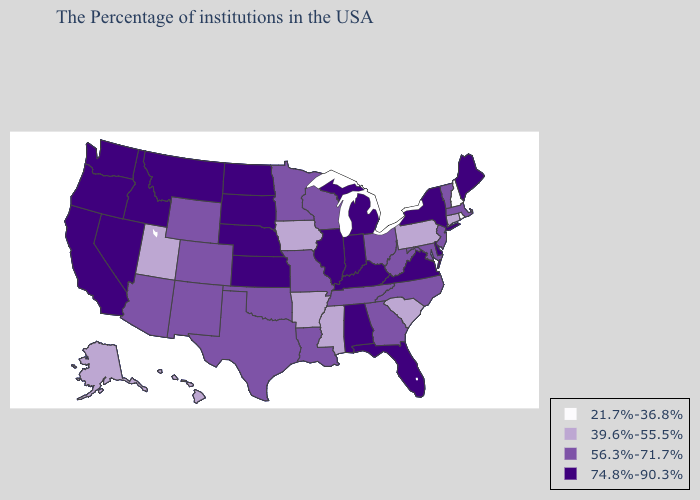What is the value of New York?
Keep it brief. 74.8%-90.3%. What is the highest value in states that border North Carolina?
Give a very brief answer. 74.8%-90.3%. What is the highest value in states that border Arkansas?
Be succinct. 56.3%-71.7%. What is the lowest value in the Northeast?
Be succinct. 21.7%-36.8%. Does New Mexico have the highest value in the West?
Concise answer only. No. What is the value of Connecticut?
Write a very short answer. 39.6%-55.5%. Is the legend a continuous bar?
Write a very short answer. No. What is the highest value in the Northeast ?
Give a very brief answer. 74.8%-90.3%. What is the value of Nebraska?
Concise answer only. 74.8%-90.3%. Among the states that border Maine , which have the lowest value?
Quick response, please. New Hampshire. What is the lowest value in the USA?
Be succinct. 21.7%-36.8%. Does New Hampshire have the lowest value in the Northeast?
Be succinct. Yes. What is the highest value in the USA?
Answer briefly. 74.8%-90.3%. What is the value of Arizona?
Be succinct. 56.3%-71.7%. 